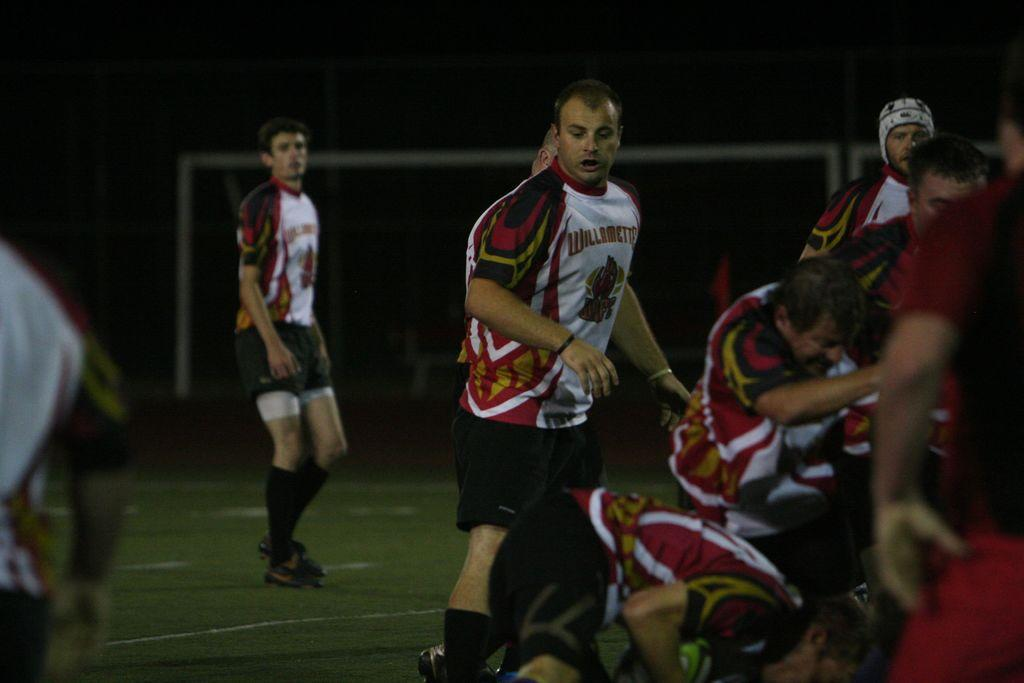<image>
Render a clear and concise summary of the photo. A player on a field has a jersey on that has a team name that starts with the letter W. 